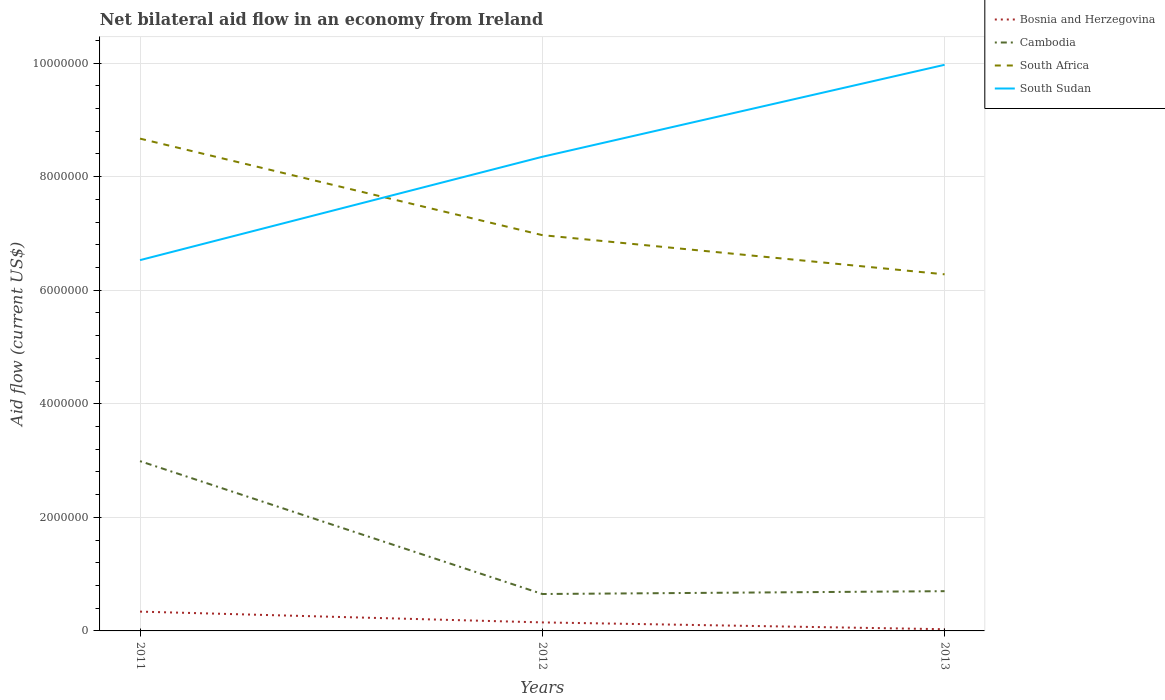How many different coloured lines are there?
Keep it short and to the point. 4. Does the line corresponding to Bosnia and Herzegovina intersect with the line corresponding to South Africa?
Offer a terse response. No. Across all years, what is the maximum net bilateral aid flow in South Sudan?
Your answer should be very brief. 6.53e+06. In which year was the net bilateral aid flow in Cambodia maximum?
Offer a terse response. 2012. What is the difference between the highest and the second highest net bilateral aid flow in Cambodia?
Offer a very short reply. 2.34e+06. Is the net bilateral aid flow in Cambodia strictly greater than the net bilateral aid flow in South Africa over the years?
Keep it short and to the point. Yes. What is the difference between two consecutive major ticks on the Y-axis?
Provide a short and direct response. 2.00e+06. Are the values on the major ticks of Y-axis written in scientific E-notation?
Offer a terse response. No. Does the graph contain any zero values?
Ensure brevity in your answer.  No. Does the graph contain grids?
Offer a very short reply. Yes. What is the title of the graph?
Provide a succinct answer. Net bilateral aid flow in an economy from Ireland. Does "Paraguay" appear as one of the legend labels in the graph?
Your answer should be compact. No. What is the Aid flow (current US$) of Cambodia in 2011?
Your response must be concise. 2.99e+06. What is the Aid flow (current US$) in South Africa in 2011?
Make the answer very short. 8.67e+06. What is the Aid flow (current US$) of South Sudan in 2011?
Offer a terse response. 6.53e+06. What is the Aid flow (current US$) in Cambodia in 2012?
Offer a very short reply. 6.50e+05. What is the Aid flow (current US$) of South Africa in 2012?
Your answer should be compact. 6.97e+06. What is the Aid flow (current US$) of South Sudan in 2012?
Keep it short and to the point. 8.35e+06. What is the Aid flow (current US$) of Cambodia in 2013?
Make the answer very short. 7.00e+05. What is the Aid flow (current US$) in South Africa in 2013?
Offer a terse response. 6.28e+06. What is the Aid flow (current US$) of South Sudan in 2013?
Keep it short and to the point. 9.97e+06. Across all years, what is the maximum Aid flow (current US$) of Bosnia and Herzegovina?
Offer a terse response. 3.40e+05. Across all years, what is the maximum Aid flow (current US$) in Cambodia?
Your response must be concise. 2.99e+06. Across all years, what is the maximum Aid flow (current US$) in South Africa?
Offer a very short reply. 8.67e+06. Across all years, what is the maximum Aid flow (current US$) of South Sudan?
Provide a short and direct response. 9.97e+06. Across all years, what is the minimum Aid flow (current US$) of Cambodia?
Offer a very short reply. 6.50e+05. Across all years, what is the minimum Aid flow (current US$) in South Africa?
Your answer should be compact. 6.28e+06. Across all years, what is the minimum Aid flow (current US$) in South Sudan?
Provide a short and direct response. 6.53e+06. What is the total Aid flow (current US$) of Bosnia and Herzegovina in the graph?
Provide a succinct answer. 5.20e+05. What is the total Aid flow (current US$) in Cambodia in the graph?
Provide a short and direct response. 4.34e+06. What is the total Aid flow (current US$) in South Africa in the graph?
Offer a terse response. 2.19e+07. What is the total Aid flow (current US$) in South Sudan in the graph?
Give a very brief answer. 2.48e+07. What is the difference between the Aid flow (current US$) in Bosnia and Herzegovina in 2011 and that in 2012?
Give a very brief answer. 1.90e+05. What is the difference between the Aid flow (current US$) of Cambodia in 2011 and that in 2012?
Provide a succinct answer. 2.34e+06. What is the difference between the Aid flow (current US$) in South Africa in 2011 and that in 2012?
Make the answer very short. 1.70e+06. What is the difference between the Aid flow (current US$) of South Sudan in 2011 and that in 2012?
Your response must be concise. -1.82e+06. What is the difference between the Aid flow (current US$) of Cambodia in 2011 and that in 2013?
Give a very brief answer. 2.29e+06. What is the difference between the Aid flow (current US$) in South Africa in 2011 and that in 2013?
Ensure brevity in your answer.  2.39e+06. What is the difference between the Aid flow (current US$) of South Sudan in 2011 and that in 2013?
Provide a succinct answer. -3.44e+06. What is the difference between the Aid flow (current US$) in Bosnia and Herzegovina in 2012 and that in 2013?
Your response must be concise. 1.20e+05. What is the difference between the Aid flow (current US$) in Cambodia in 2012 and that in 2013?
Your response must be concise. -5.00e+04. What is the difference between the Aid flow (current US$) of South Africa in 2012 and that in 2013?
Keep it short and to the point. 6.90e+05. What is the difference between the Aid flow (current US$) of South Sudan in 2012 and that in 2013?
Your response must be concise. -1.62e+06. What is the difference between the Aid flow (current US$) in Bosnia and Herzegovina in 2011 and the Aid flow (current US$) in Cambodia in 2012?
Provide a succinct answer. -3.10e+05. What is the difference between the Aid flow (current US$) in Bosnia and Herzegovina in 2011 and the Aid flow (current US$) in South Africa in 2012?
Offer a terse response. -6.63e+06. What is the difference between the Aid flow (current US$) in Bosnia and Herzegovina in 2011 and the Aid flow (current US$) in South Sudan in 2012?
Your answer should be compact. -8.01e+06. What is the difference between the Aid flow (current US$) of Cambodia in 2011 and the Aid flow (current US$) of South Africa in 2012?
Provide a short and direct response. -3.98e+06. What is the difference between the Aid flow (current US$) in Cambodia in 2011 and the Aid flow (current US$) in South Sudan in 2012?
Keep it short and to the point. -5.36e+06. What is the difference between the Aid flow (current US$) of South Africa in 2011 and the Aid flow (current US$) of South Sudan in 2012?
Your response must be concise. 3.20e+05. What is the difference between the Aid flow (current US$) in Bosnia and Herzegovina in 2011 and the Aid flow (current US$) in Cambodia in 2013?
Your answer should be very brief. -3.60e+05. What is the difference between the Aid flow (current US$) of Bosnia and Herzegovina in 2011 and the Aid flow (current US$) of South Africa in 2013?
Your answer should be very brief. -5.94e+06. What is the difference between the Aid flow (current US$) of Bosnia and Herzegovina in 2011 and the Aid flow (current US$) of South Sudan in 2013?
Your response must be concise. -9.63e+06. What is the difference between the Aid flow (current US$) of Cambodia in 2011 and the Aid flow (current US$) of South Africa in 2013?
Offer a terse response. -3.29e+06. What is the difference between the Aid flow (current US$) of Cambodia in 2011 and the Aid flow (current US$) of South Sudan in 2013?
Provide a succinct answer. -6.98e+06. What is the difference between the Aid flow (current US$) of South Africa in 2011 and the Aid flow (current US$) of South Sudan in 2013?
Keep it short and to the point. -1.30e+06. What is the difference between the Aid flow (current US$) of Bosnia and Herzegovina in 2012 and the Aid flow (current US$) of Cambodia in 2013?
Make the answer very short. -5.50e+05. What is the difference between the Aid flow (current US$) of Bosnia and Herzegovina in 2012 and the Aid flow (current US$) of South Africa in 2013?
Your answer should be very brief. -6.13e+06. What is the difference between the Aid flow (current US$) of Bosnia and Herzegovina in 2012 and the Aid flow (current US$) of South Sudan in 2013?
Offer a very short reply. -9.82e+06. What is the difference between the Aid flow (current US$) of Cambodia in 2012 and the Aid flow (current US$) of South Africa in 2013?
Your answer should be very brief. -5.63e+06. What is the difference between the Aid flow (current US$) of Cambodia in 2012 and the Aid flow (current US$) of South Sudan in 2013?
Your response must be concise. -9.32e+06. What is the average Aid flow (current US$) in Bosnia and Herzegovina per year?
Provide a succinct answer. 1.73e+05. What is the average Aid flow (current US$) in Cambodia per year?
Provide a short and direct response. 1.45e+06. What is the average Aid flow (current US$) of South Africa per year?
Your response must be concise. 7.31e+06. What is the average Aid flow (current US$) of South Sudan per year?
Make the answer very short. 8.28e+06. In the year 2011, what is the difference between the Aid flow (current US$) in Bosnia and Herzegovina and Aid flow (current US$) in Cambodia?
Your answer should be compact. -2.65e+06. In the year 2011, what is the difference between the Aid flow (current US$) in Bosnia and Herzegovina and Aid flow (current US$) in South Africa?
Make the answer very short. -8.33e+06. In the year 2011, what is the difference between the Aid flow (current US$) of Bosnia and Herzegovina and Aid flow (current US$) of South Sudan?
Offer a terse response. -6.19e+06. In the year 2011, what is the difference between the Aid flow (current US$) in Cambodia and Aid flow (current US$) in South Africa?
Give a very brief answer. -5.68e+06. In the year 2011, what is the difference between the Aid flow (current US$) of Cambodia and Aid flow (current US$) of South Sudan?
Offer a very short reply. -3.54e+06. In the year 2011, what is the difference between the Aid flow (current US$) in South Africa and Aid flow (current US$) in South Sudan?
Offer a very short reply. 2.14e+06. In the year 2012, what is the difference between the Aid flow (current US$) of Bosnia and Herzegovina and Aid flow (current US$) of Cambodia?
Provide a short and direct response. -5.00e+05. In the year 2012, what is the difference between the Aid flow (current US$) in Bosnia and Herzegovina and Aid flow (current US$) in South Africa?
Make the answer very short. -6.82e+06. In the year 2012, what is the difference between the Aid flow (current US$) in Bosnia and Herzegovina and Aid flow (current US$) in South Sudan?
Provide a succinct answer. -8.20e+06. In the year 2012, what is the difference between the Aid flow (current US$) of Cambodia and Aid flow (current US$) of South Africa?
Offer a very short reply. -6.32e+06. In the year 2012, what is the difference between the Aid flow (current US$) in Cambodia and Aid flow (current US$) in South Sudan?
Your answer should be compact. -7.70e+06. In the year 2012, what is the difference between the Aid flow (current US$) in South Africa and Aid flow (current US$) in South Sudan?
Your answer should be compact. -1.38e+06. In the year 2013, what is the difference between the Aid flow (current US$) of Bosnia and Herzegovina and Aid flow (current US$) of Cambodia?
Provide a succinct answer. -6.70e+05. In the year 2013, what is the difference between the Aid flow (current US$) of Bosnia and Herzegovina and Aid flow (current US$) of South Africa?
Provide a succinct answer. -6.25e+06. In the year 2013, what is the difference between the Aid flow (current US$) in Bosnia and Herzegovina and Aid flow (current US$) in South Sudan?
Offer a very short reply. -9.94e+06. In the year 2013, what is the difference between the Aid flow (current US$) of Cambodia and Aid flow (current US$) of South Africa?
Your answer should be very brief. -5.58e+06. In the year 2013, what is the difference between the Aid flow (current US$) of Cambodia and Aid flow (current US$) of South Sudan?
Your answer should be compact. -9.27e+06. In the year 2013, what is the difference between the Aid flow (current US$) in South Africa and Aid flow (current US$) in South Sudan?
Ensure brevity in your answer.  -3.69e+06. What is the ratio of the Aid flow (current US$) of Bosnia and Herzegovina in 2011 to that in 2012?
Your response must be concise. 2.27. What is the ratio of the Aid flow (current US$) in Cambodia in 2011 to that in 2012?
Your response must be concise. 4.6. What is the ratio of the Aid flow (current US$) of South Africa in 2011 to that in 2012?
Your answer should be compact. 1.24. What is the ratio of the Aid flow (current US$) in South Sudan in 2011 to that in 2012?
Offer a very short reply. 0.78. What is the ratio of the Aid flow (current US$) of Bosnia and Herzegovina in 2011 to that in 2013?
Make the answer very short. 11.33. What is the ratio of the Aid flow (current US$) of Cambodia in 2011 to that in 2013?
Keep it short and to the point. 4.27. What is the ratio of the Aid flow (current US$) of South Africa in 2011 to that in 2013?
Ensure brevity in your answer.  1.38. What is the ratio of the Aid flow (current US$) in South Sudan in 2011 to that in 2013?
Offer a very short reply. 0.66. What is the ratio of the Aid flow (current US$) in Bosnia and Herzegovina in 2012 to that in 2013?
Your response must be concise. 5. What is the ratio of the Aid flow (current US$) in Cambodia in 2012 to that in 2013?
Ensure brevity in your answer.  0.93. What is the ratio of the Aid flow (current US$) of South Africa in 2012 to that in 2013?
Make the answer very short. 1.11. What is the ratio of the Aid flow (current US$) of South Sudan in 2012 to that in 2013?
Provide a short and direct response. 0.84. What is the difference between the highest and the second highest Aid flow (current US$) of Cambodia?
Give a very brief answer. 2.29e+06. What is the difference between the highest and the second highest Aid flow (current US$) in South Africa?
Offer a very short reply. 1.70e+06. What is the difference between the highest and the second highest Aid flow (current US$) in South Sudan?
Give a very brief answer. 1.62e+06. What is the difference between the highest and the lowest Aid flow (current US$) of Bosnia and Herzegovina?
Your response must be concise. 3.10e+05. What is the difference between the highest and the lowest Aid flow (current US$) of Cambodia?
Make the answer very short. 2.34e+06. What is the difference between the highest and the lowest Aid flow (current US$) of South Africa?
Make the answer very short. 2.39e+06. What is the difference between the highest and the lowest Aid flow (current US$) of South Sudan?
Ensure brevity in your answer.  3.44e+06. 